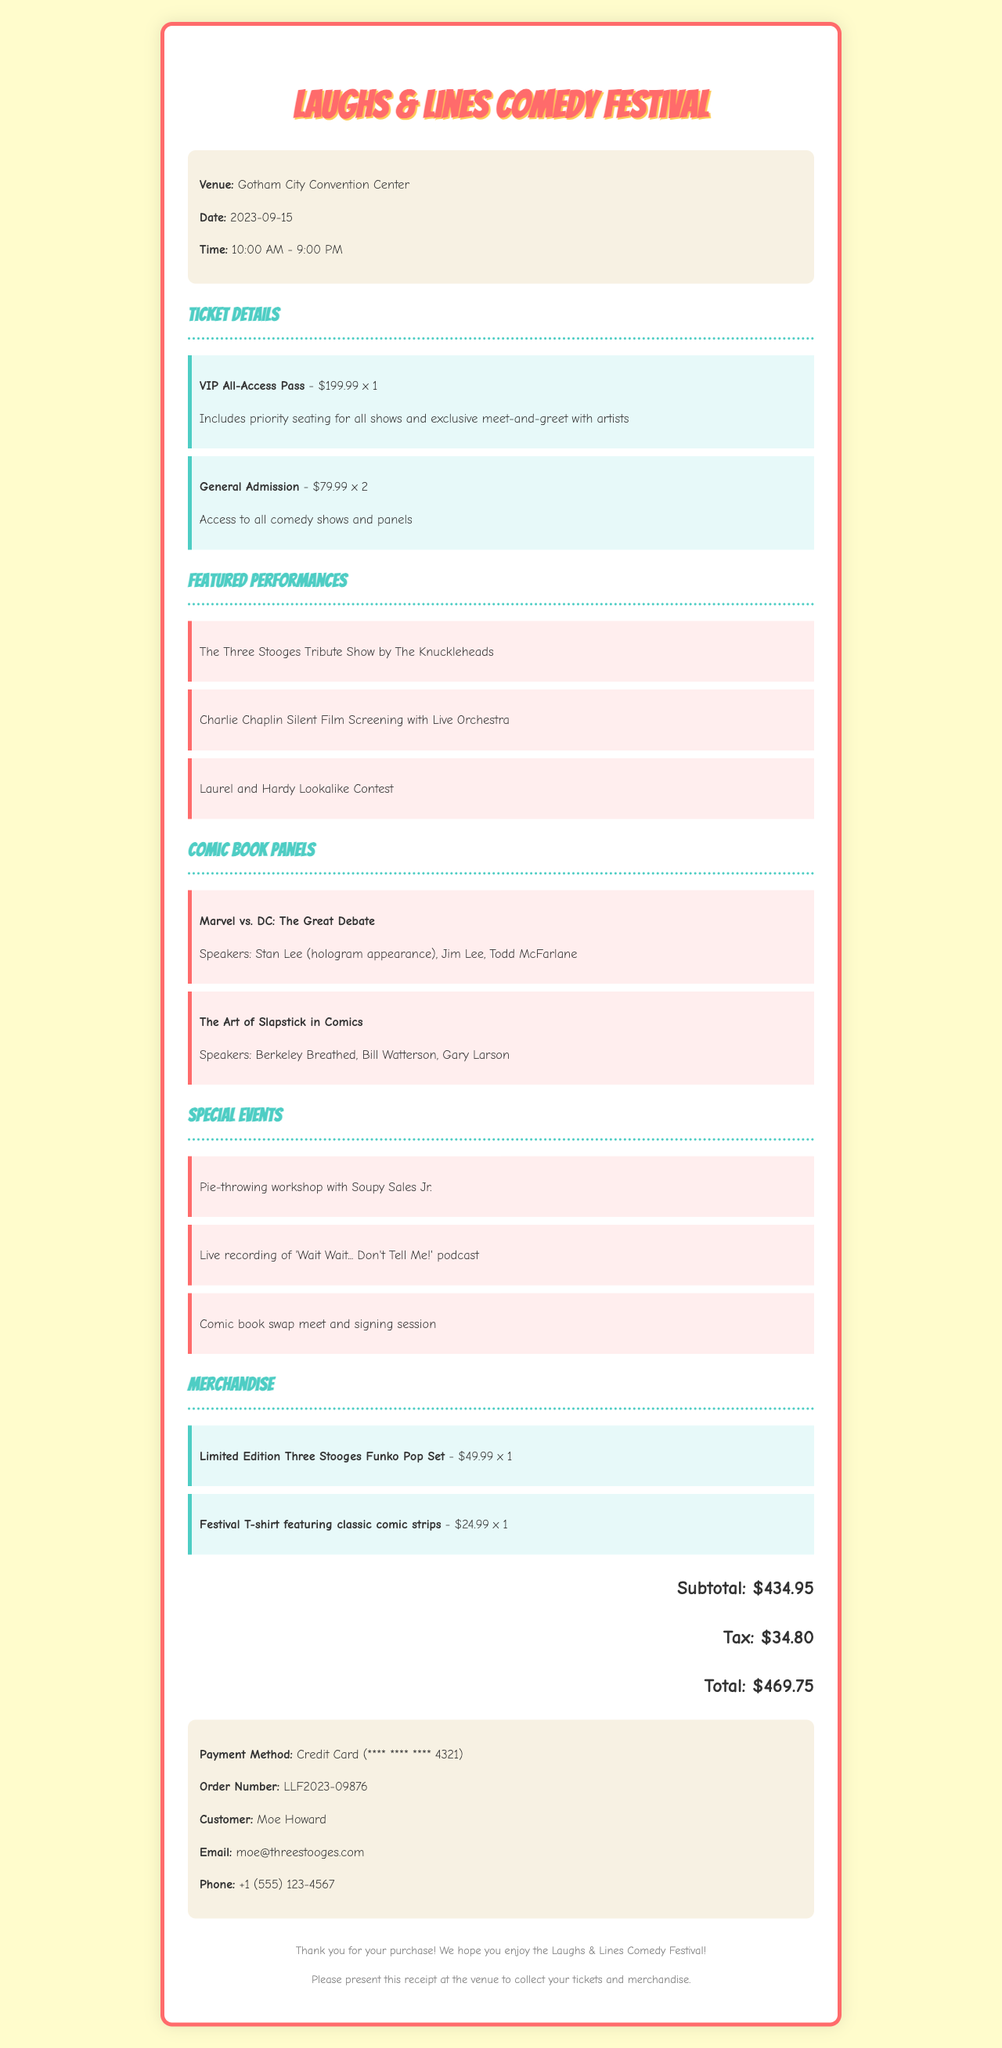What is the name of the event? The event name is given at the beginning of the document.
Answer: Laughs & Lines Comedy Festival What is the date of the festival? The date is specified in the event details section.
Answer: 2023-09-15 How many General Admission tickets were purchased? The quantity is provided in the ticket details section for General Admission.
Answer: 2 Who is the speaker for "Marvel vs. DC: The Great Debate"? The speakers for each panel are listed under the comic book panels section.
Answer: Stan Lee (hologram appearance) What is the price of the VIP All-Access Pass? The price of each ticket type is mentioned in the ticket details.
Answer: 199.99 What is the total paid amount? The total amount paid is specified in the totals section of the document.
Answer: 469.75 How many special events are listed? The number of special events can be counted from the list in the document.
Answer: 3 What type of merchandise was purchased? The items under the merchandise section indicate what was bought.
Answer: Limited Edition Three Stooges Funko Pop Set What is the order number? The order number is uniquely given in the payment details section.
Answer: LLF2023-09876 